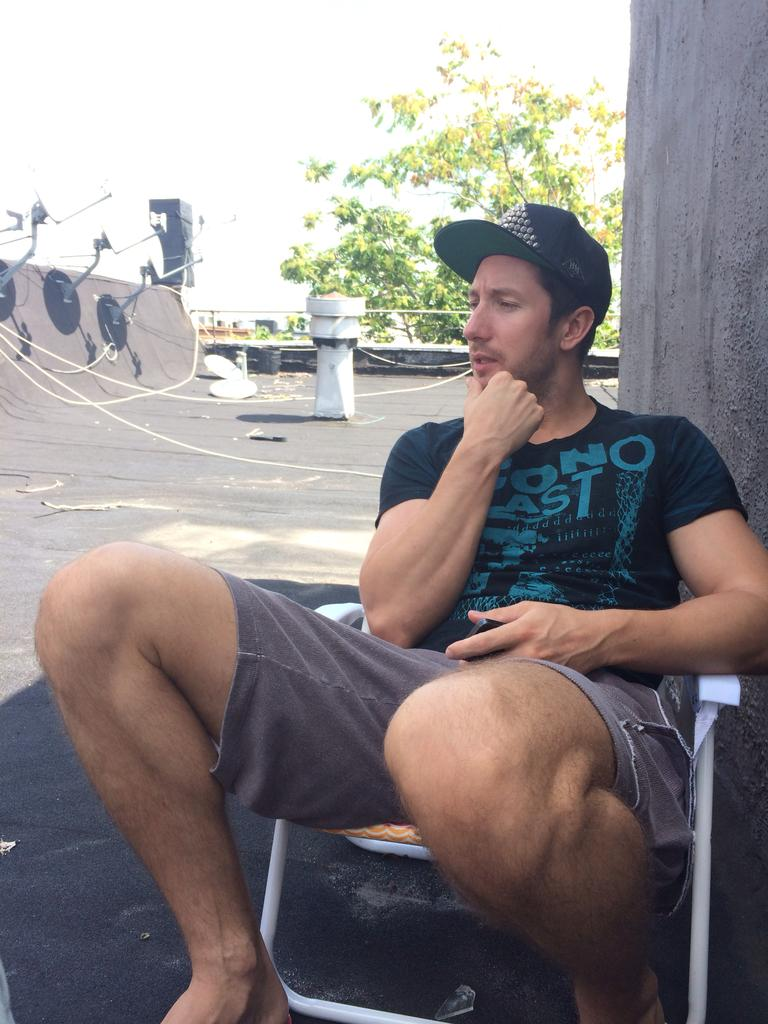What is the person in the image doing? The person is sitting on a chair in the image. What can be seen behind the person? There is a wall visible behind the person. What is visible in the background of the image? There is a tree visible in the background. What is on the left side of the image? There are objects on the left side of the image. What is visible at the top of the image? The sky is visible at the top of the image. Can you tell me how many pins the stranger is holding in the image? There is no stranger present in the image, and therefore no pins can be observed. What type of lead is the person using to communicate with the tree in the image? There is no lead present in the image, and the person is not communicating with the tree. 